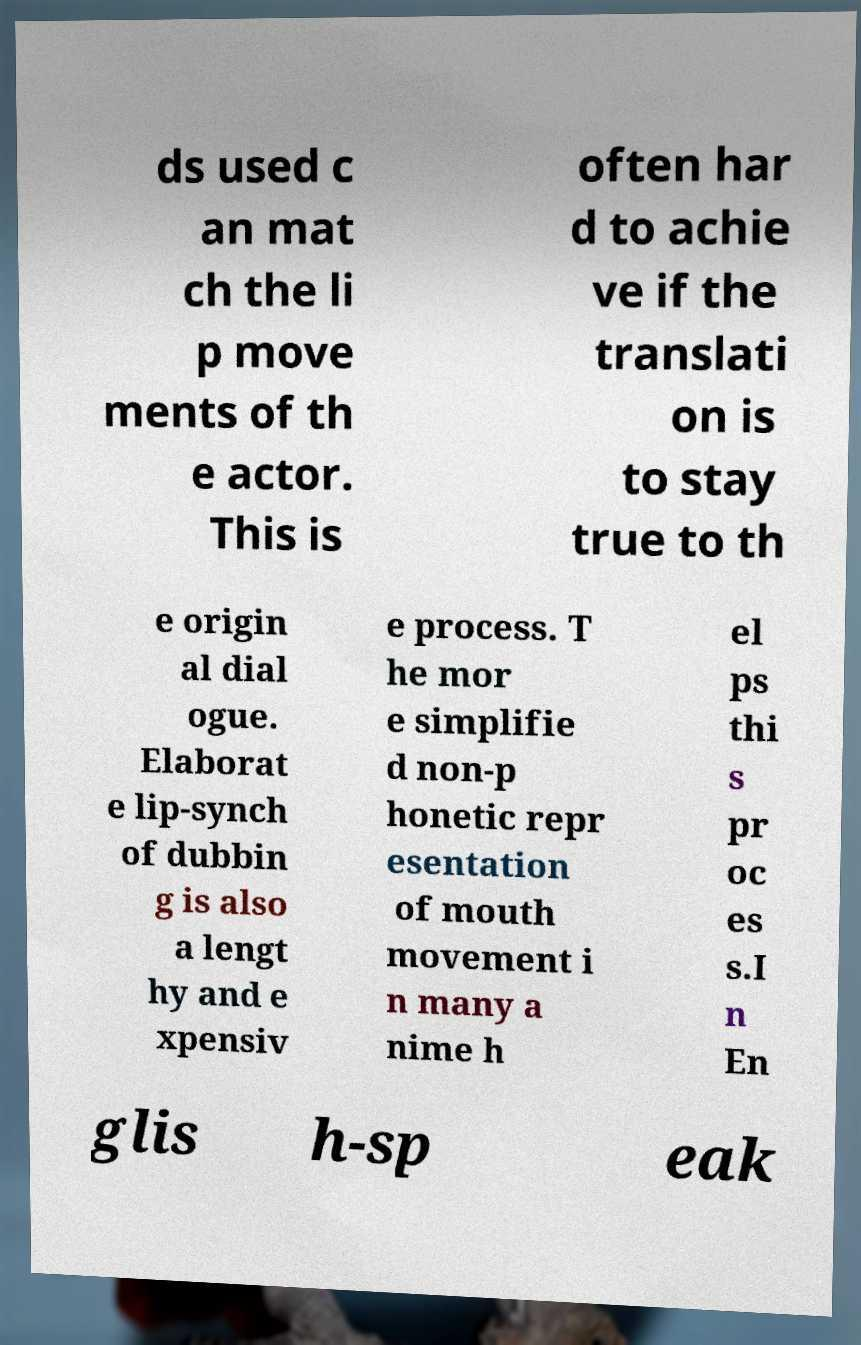For documentation purposes, I need the text within this image transcribed. Could you provide that? ds used c an mat ch the li p move ments of th e actor. This is often har d to achie ve if the translati on is to stay true to th e origin al dial ogue. Elaborat e lip-synch of dubbin g is also a lengt hy and e xpensiv e process. T he mor e simplifie d non-p honetic repr esentation of mouth movement i n many a nime h el ps thi s pr oc es s.I n En glis h-sp eak 